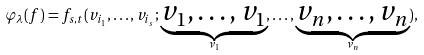<formula> <loc_0><loc_0><loc_500><loc_500>\varphi _ { \lambda } ( { f } ) = f _ { s , t } ( v _ { i _ { 1 } } , \dots , v _ { i _ { s } } ; \underbrace { v _ { 1 } , \dots , v _ { 1 } } _ { \nu _ { 1 } } , \dots , \underbrace { v _ { n } , \dots , v _ { n } } _ { \nu _ { n } } ) ,</formula> 